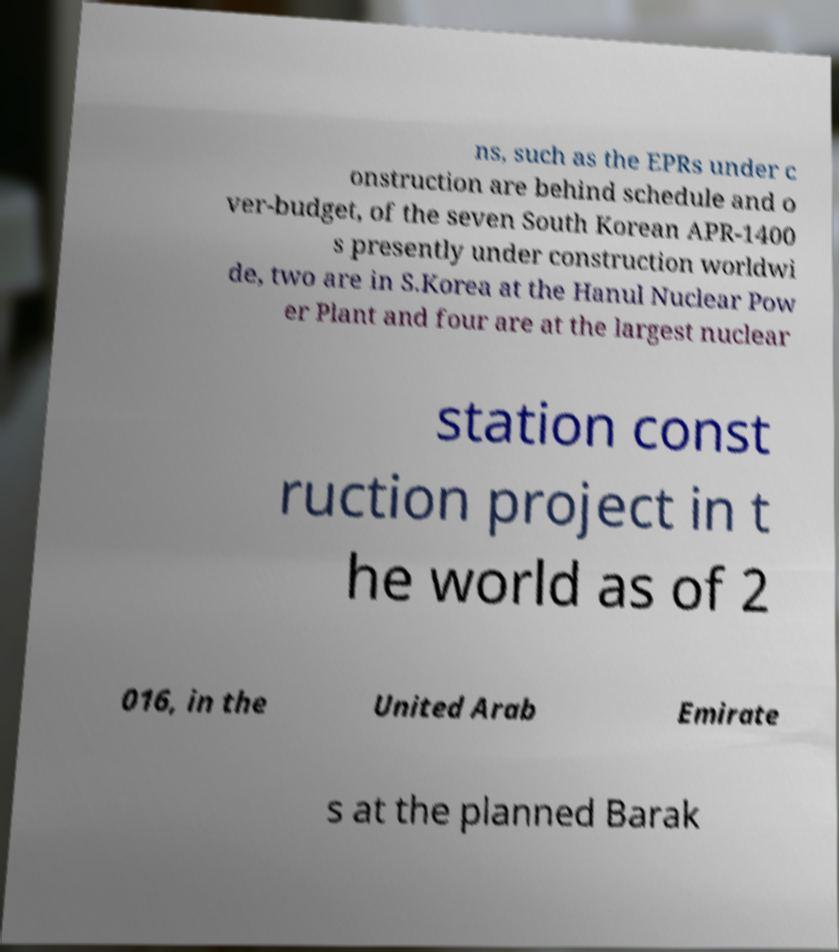For documentation purposes, I need the text within this image transcribed. Could you provide that? ns, such as the EPRs under c onstruction are behind schedule and o ver-budget, of the seven South Korean APR-1400 s presently under construction worldwi de, two are in S.Korea at the Hanul Nuclear Pow er Plant and four are at the largest nuclear station const ruction project in t he world as of 2 016, in the United Arab Emirate s at the planned Barak 